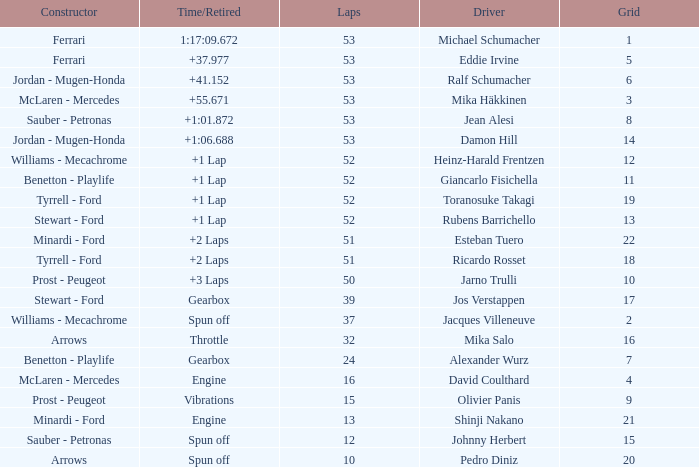What is the grid total for ralf schumacher racing over 53 laps? None. 